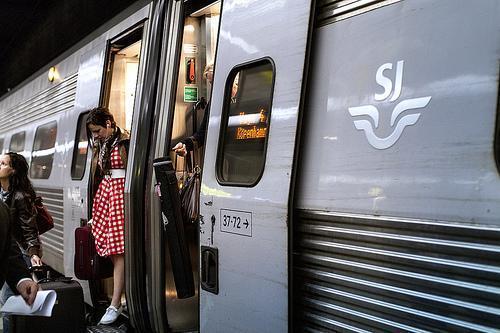How many people are in this picture?
Give a very brief answer. 2. 